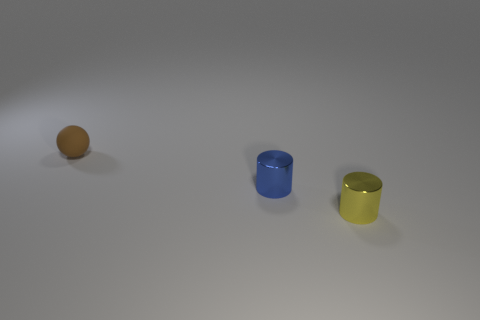Can you tell if there’s any text or branding on these objects? From this angle, there is no visible text or branding on the objects. They appear to have plain surfaces without any discernible marks. 